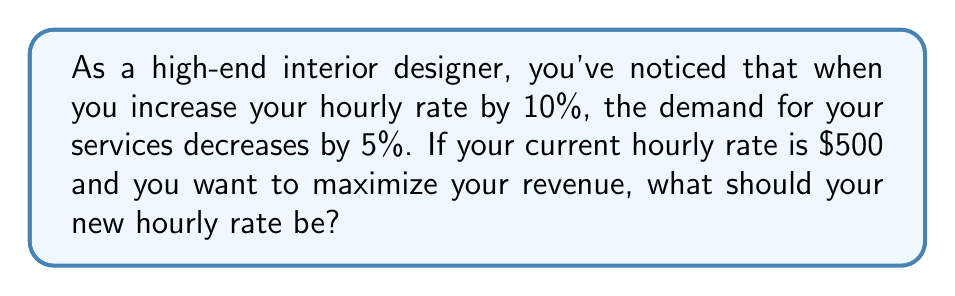Solve this math problem. To solve this problem, we need to use the concept of price elasticity of demand and find the optimal pricing strategy. Let's approach this step-by-step:

1) First, we calculate the price elasticity of demand:

   Price Elasticity = (% Change in Quantity Demanded) / (% Change in Price)
   $$ E = \frac{-5\%}{10\%} = -0.5 $$

2) The demand is inelastic since |E| < 1. This means that a price increase will lead to an increase in total revenue.

3) To maximize revenue, we need to set the price where the elasticity is equal to -1. We can use the following formula:

   $$ E = -1 = \frac{P}{P + \Delta P} \cdot \frac{\Delta Q}{Q} $$

   Where P is the current price, ΔP is the change in price, and ΔQ/Q is the percentage change in quantity.

4) We know that for a 10% increase in price, there's a 5% decrease in demand. Let's express this in terms of our formula:

   $$ -0.5 = \frac{500}{500 + 50} \cdot \frac{-5}{100} $$

5) To find the optimal price, we need to solve for ΔP when E = -1:

   $$ -1 = \frac{500}{500 + \Delta P} \cdot \frac{-5\Delta P}{50} $$

6) Simplifying and solving for ΔP:

   $$ 500 + \Delta P = 10\Delta P $$
   $$ 500 = 9\Delta P $$
   $$ \Delta P = \frac{500}{9} \approx 55.56 $$

7) Therefore, the new optimal price should be:

   $$ 500 + 55.56 = 555.56 $$
Answer: $555.56 per hour 